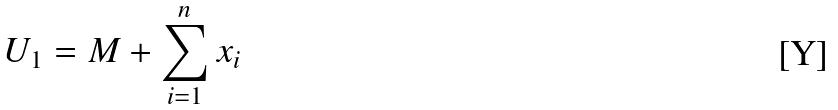<formula> <loc_0><loc_0><loc_500><loc_500>U _ { 1 } = M + \sum _ { i = 1 } ^ { n } x _ { i }</formula> 